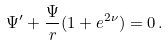Convert formula to latex. <formula><loc_0><loc_0><loc_500><loc_500>\Psi ^ { \prime } + \frac { \Psi } { r } ( 1 + e ^ { 2 \nu } ) = 0 \, .</formula> 